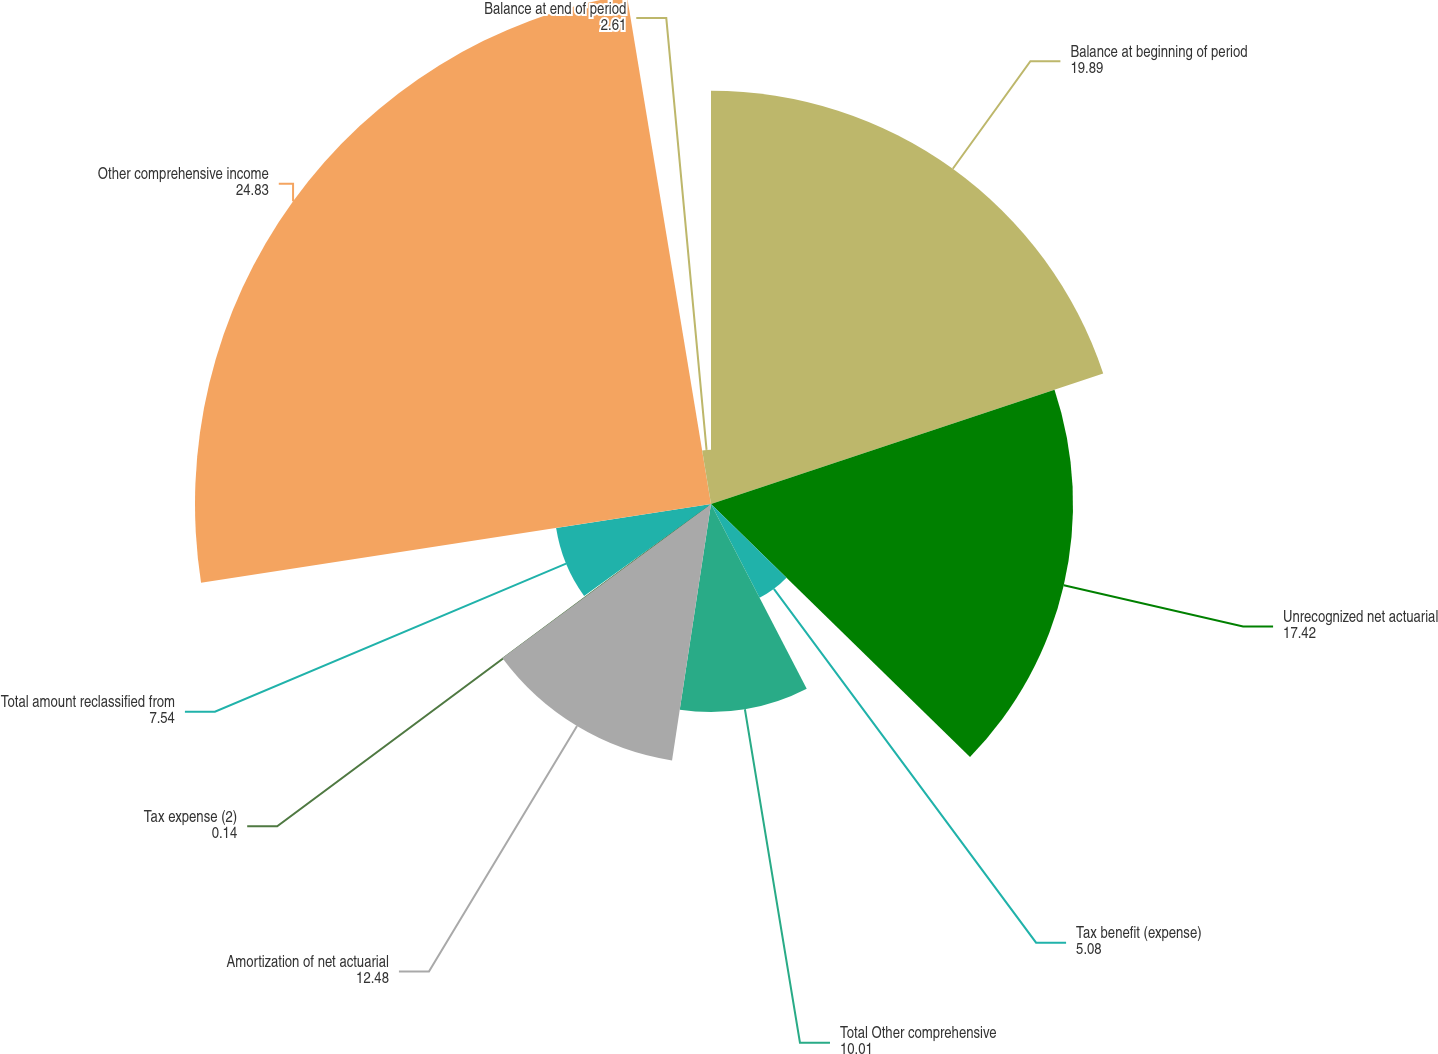Convert chart to OTSL. <chart><loc_0><loc_0><loc_500><loc_500><pie_chart><fcel>Balance at beginning of period<fcel>Unrecognized net actuarial<fcel>Tax benefit (expense)<fcel>Total Other comprehensive<fcel>Amortization of net actuarial<fcel>Tax expense (2)<fcel>Total amount reclassified from<fcel>Other comprehensive income<fcel>Balance at end of period<nl><fcel>19.89%<fcel>17.42%<fcel>5.08%<fcel>10.01%<fcel>12.48%<fcel>0.14%<fcel>7.54%<fcel>24.83%<fcel>2.61%<nl></chart> 